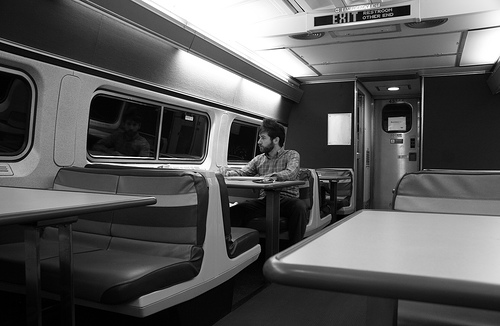Please transcribe the text information in this image. EXIT END 